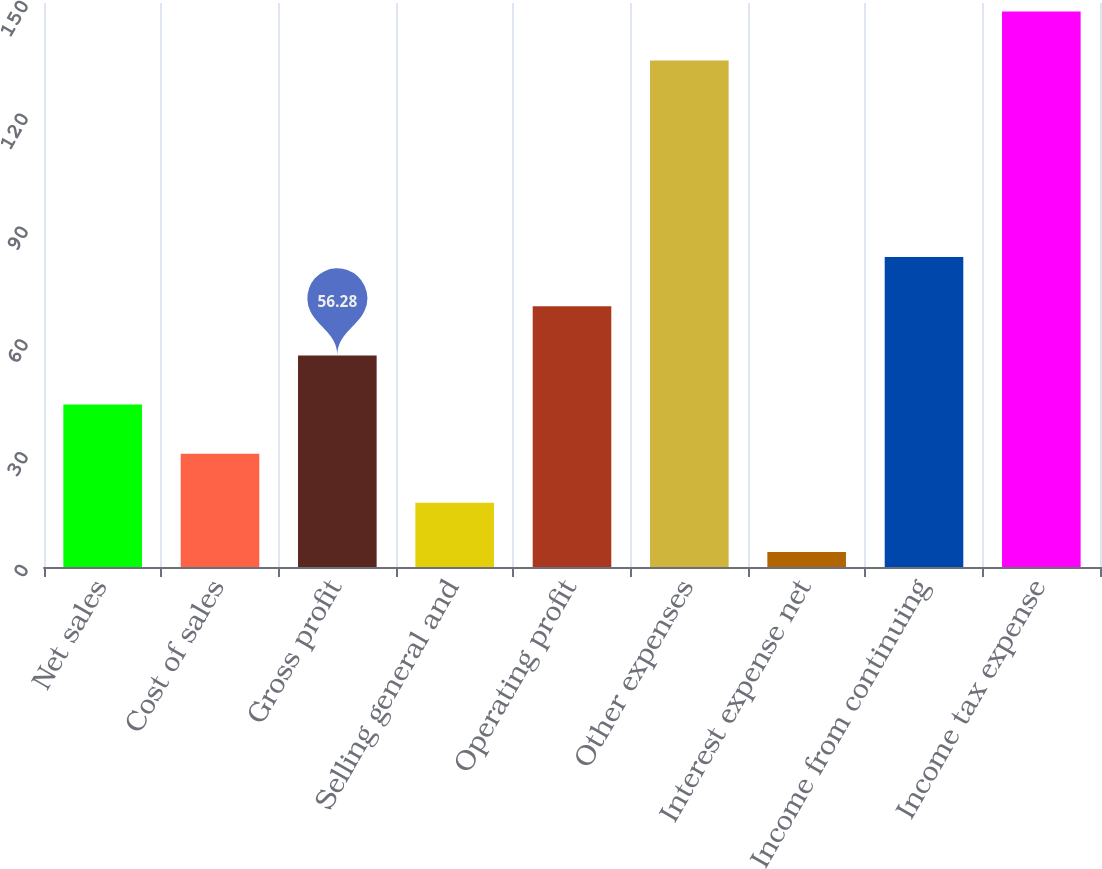Convert chart to OTSL. <chart><loc_0><loc_0><loc_500><loc_500><bar_chart><fcel>Net sales<fcel>Cost of sales<fcel>Gross profit<fcel>Selling general and<fcel>Operating profit<fcel>Other expenses<fcel>Interest expense net<fcel>Income from continuing<fcel>Income tax expense<nl><fcel>43.21<fcel>30.14<fcel>56.28<fcel>17.07<fcel>69.35<fcel>134.7<fcel>4<fcel>82.42<fcel>147.77<nl></chart> 